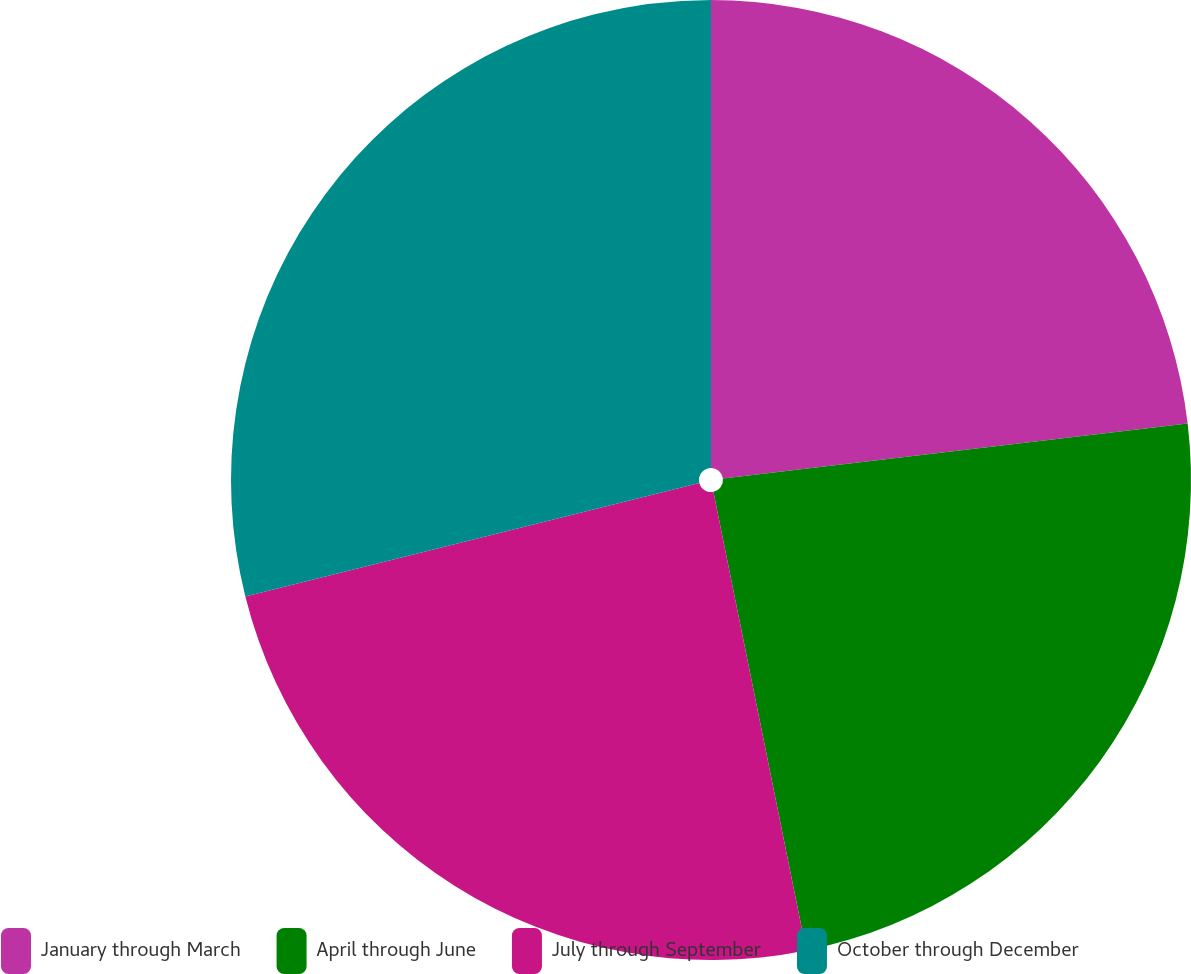Convert chart to OTSL. <chart><loc_0><loc_0><loc_500><loc_500><pie_chart><fcel>January through March<fcel>April through June<fcel>July through September<fcel>October through December<nl><fcel>23.12%<fcel>23.7%<fcel>24.28%<fcel>28.9%<nl></chart> 